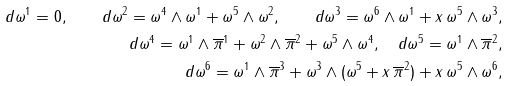<formula> <loc_0><loc_0><loc_500><loc_500>d \omega ^ { 1 } = 0 , \quad d \omega ^ { 2 } = \omega ^ { 4 } \wedge \omega ^ { 1 } + \omega ^ { 5 } \wedge \omega ^ { 2 } , \quad d \omega ^ { 3 } = \omega ^ { 6 } \wedge \omega ^ { 1 } + x \, \omega ^ { 5 } \wedge \omega ^ { 3 } , \\ d \omega ^ { 4 } = \omega ^ { 1 } \wedge \overline { \pi } ^ { 1 } + \omega ^ { 2 } \wedge \overline { \pi } ^ { 2 } + \omega ^ { 5 } \wedge \omega ^ { 4 } , \quad d \omega ^ { 5 } = \omega ^ { 1 } \wedge \overline { \pi } ^ { 2 } , \\ d \omega ^ { 6 } = \omega ^ { 1 } \wedge \overline { \pi } ^ { 3 } + \omega ^ { 3 } \wedge ( \omega ^ { 5 } + x \, \overline { \pi } ^ { 2 } ) + x \, \omega ^ { 5 } \wedge \omega ^ { 6 } ,</formula> 